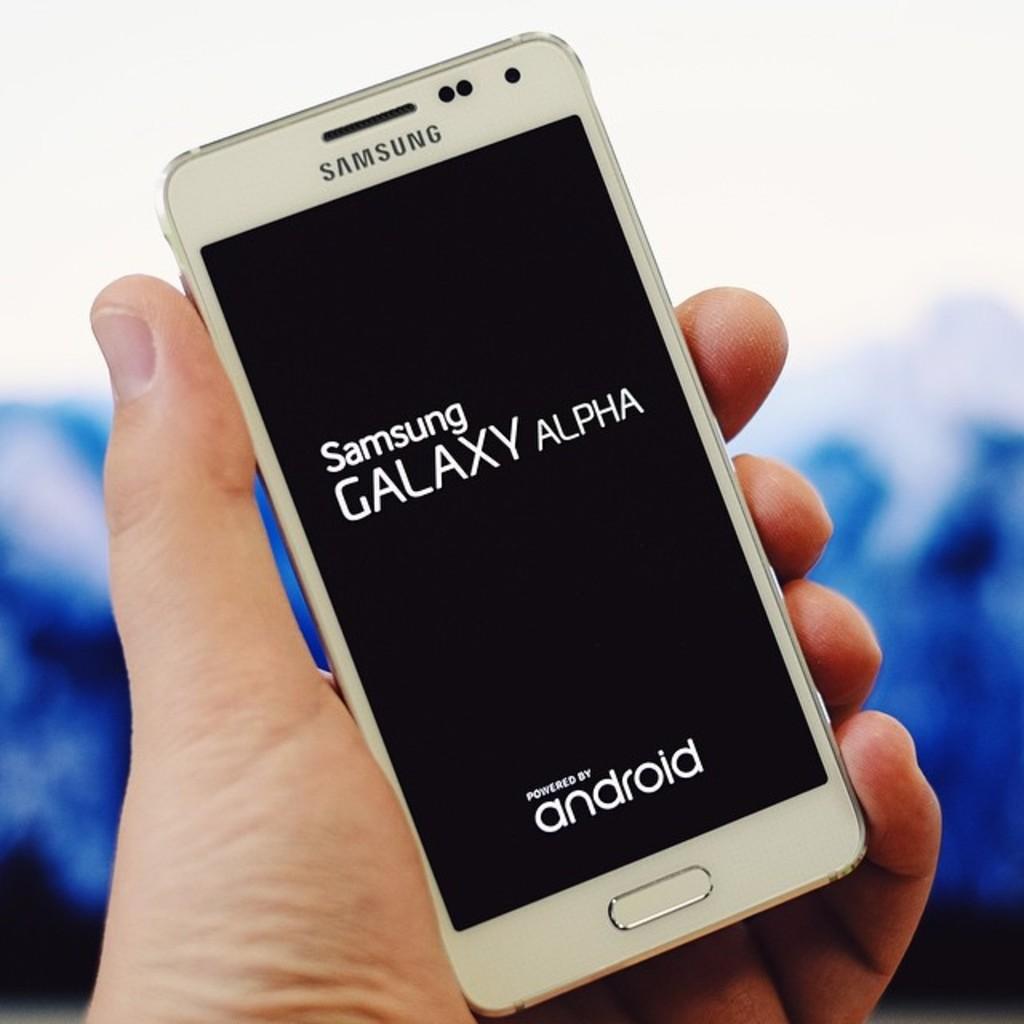What brand of phone?
Provide a short and direct response. Samsung. 